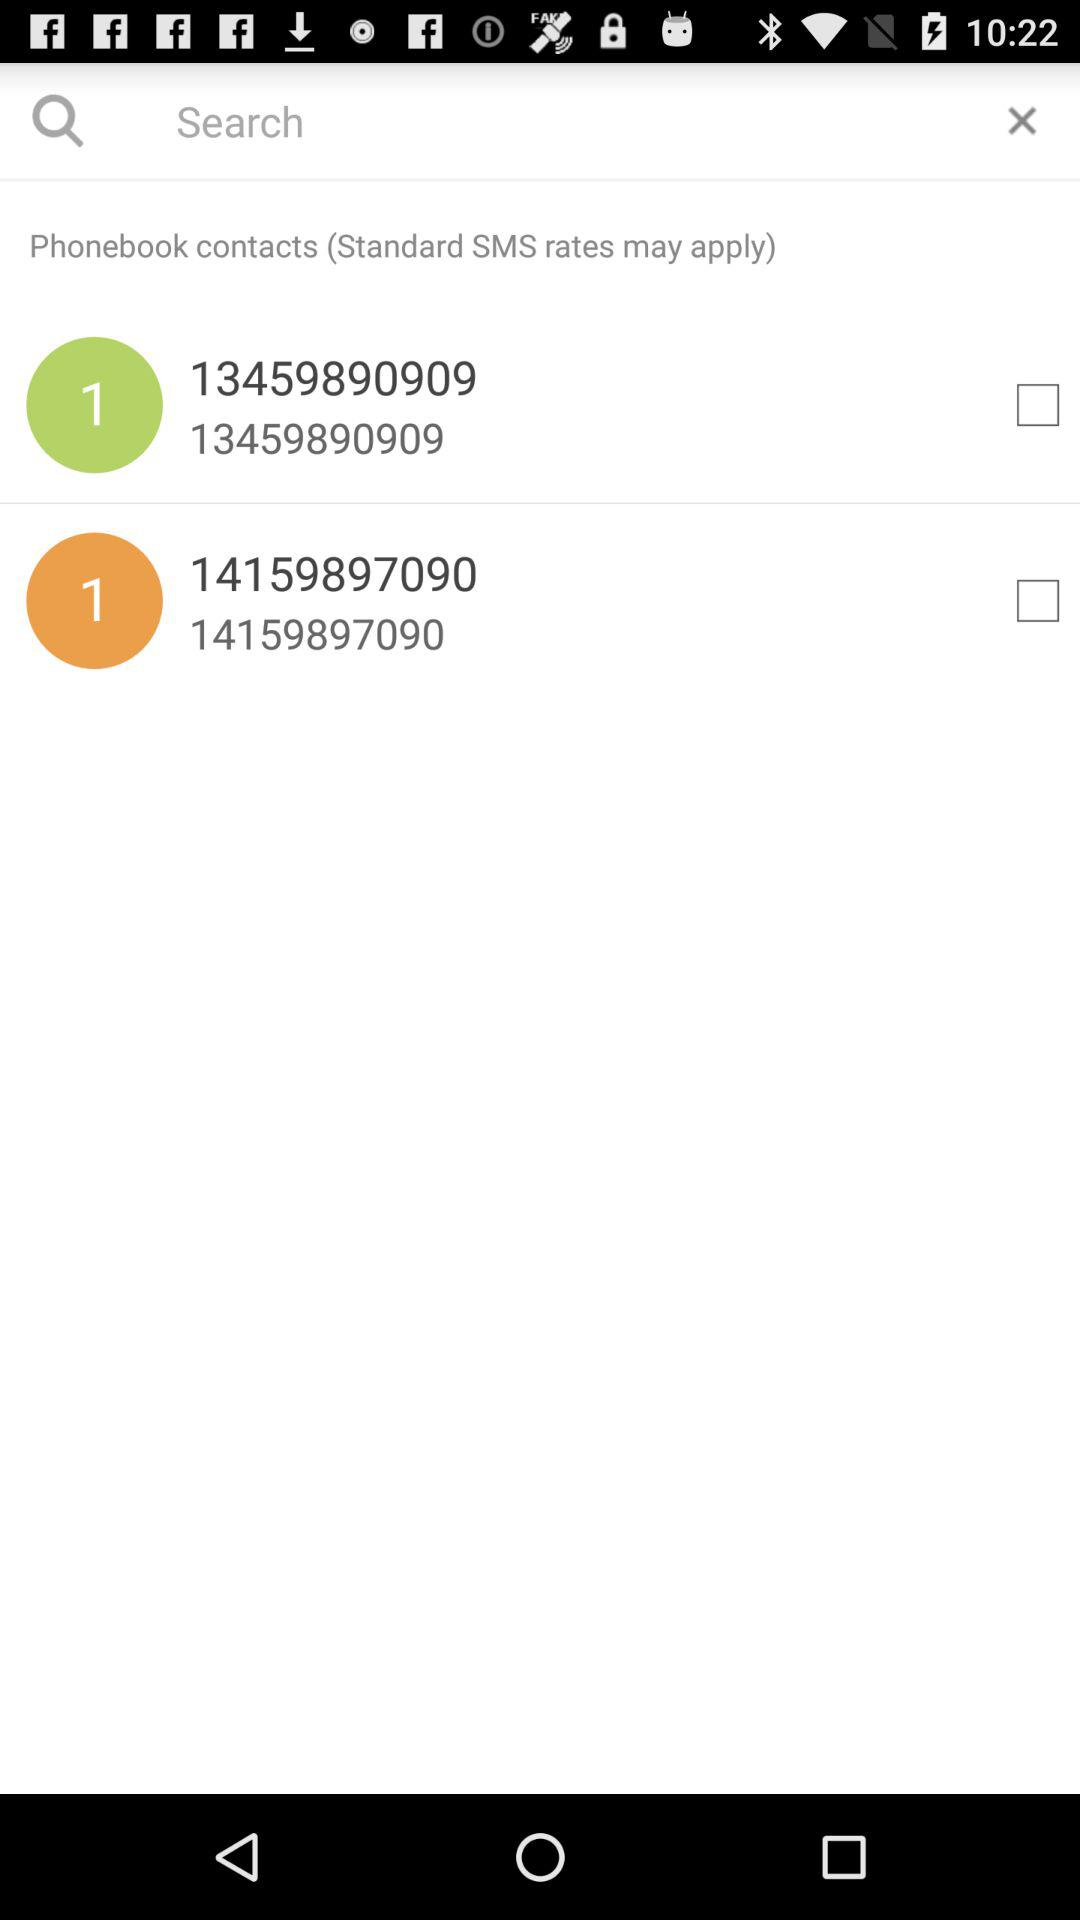What is the contact number that starts with 13? The contact number is 13459890909. 